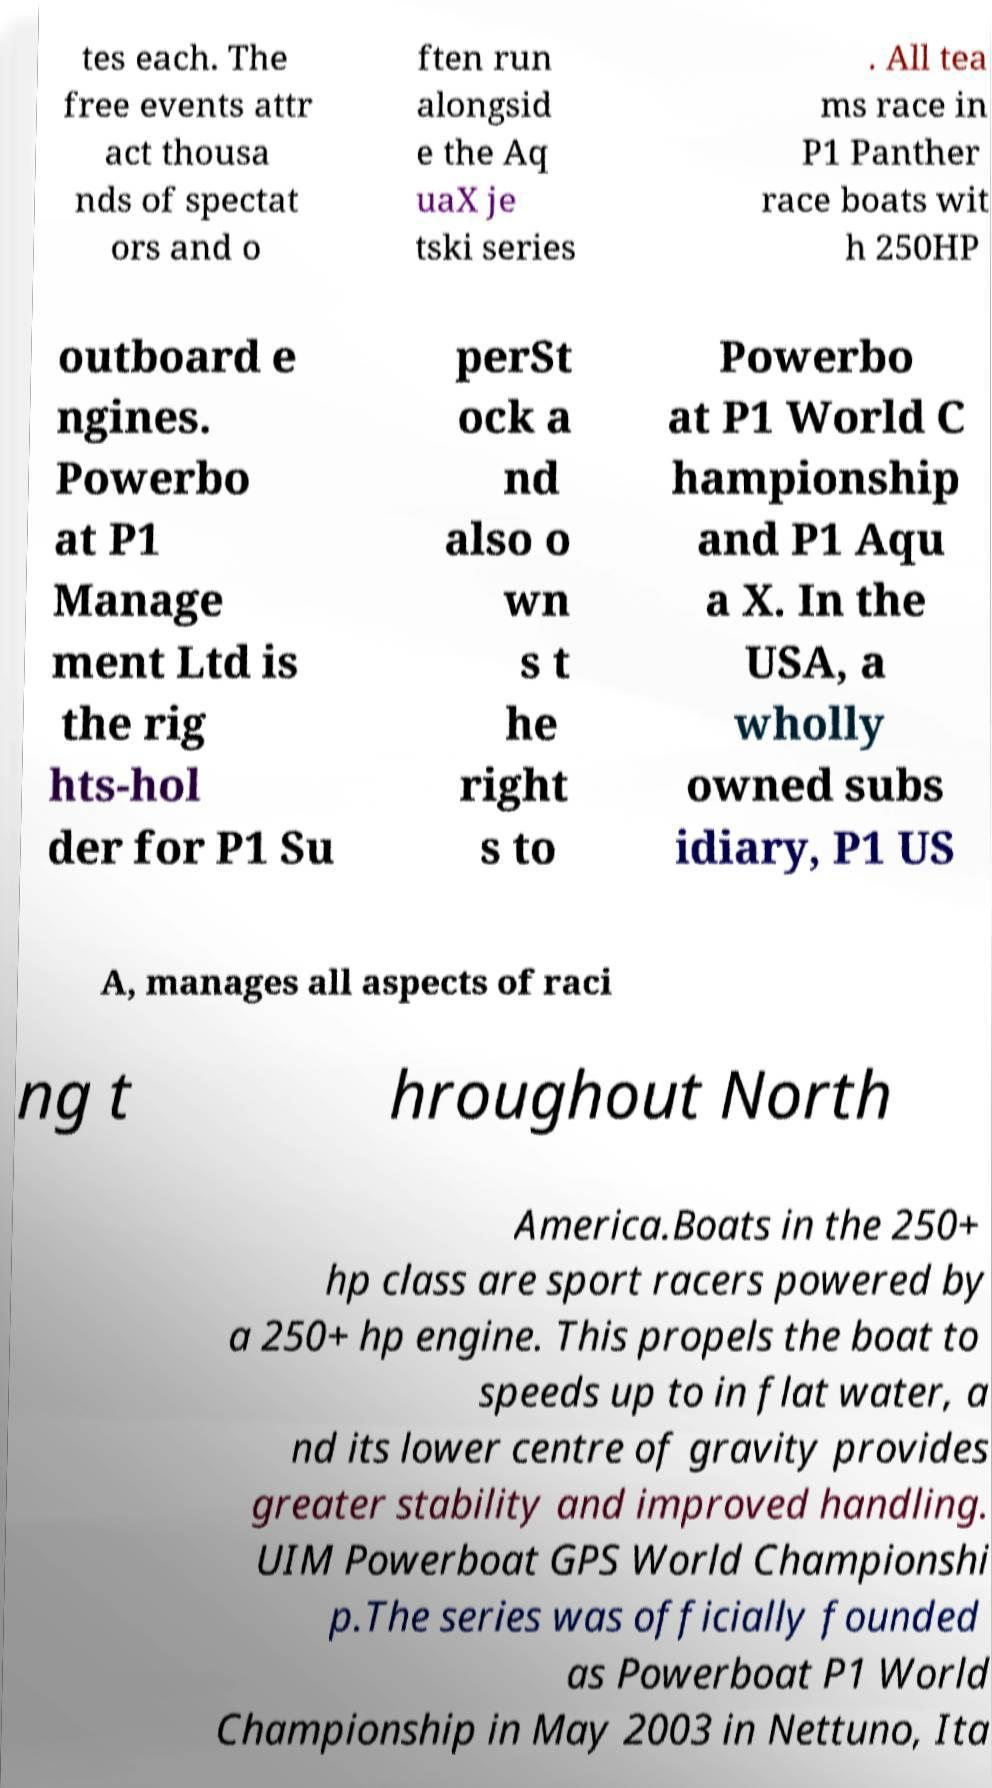Could you extract and type out the text from this image? tes each. The free events attr act thousa nds of spectat ors and o ften run alongsid e the Aq uaX je tski series . All tea ms race in P1 Panther race boats wit h 250HP outboard e ngines. Powerbo at P1 Manage ment Ltd is the rig hts-hol der for P1 Su perSt ock a nd also o wn s t he right s to Powerbo at P1 World C hampionship and P1 Aqu a X. In the USA, a wholly owned subs idiary, P1 US A, manages all aspects of raci ng t hroughout North America.Boats in the 250+ hp class are sport racers powered by a 250+ hp engine. This propels the boat to speeds up to in flat water, a nd its lower centre of gravity provides greater stability and improved handling. UIM Powerboat GPS World Championshi p.The series was officially founded as Powerboat P1 World Championship in May 2003 in Nettuno, Ita 